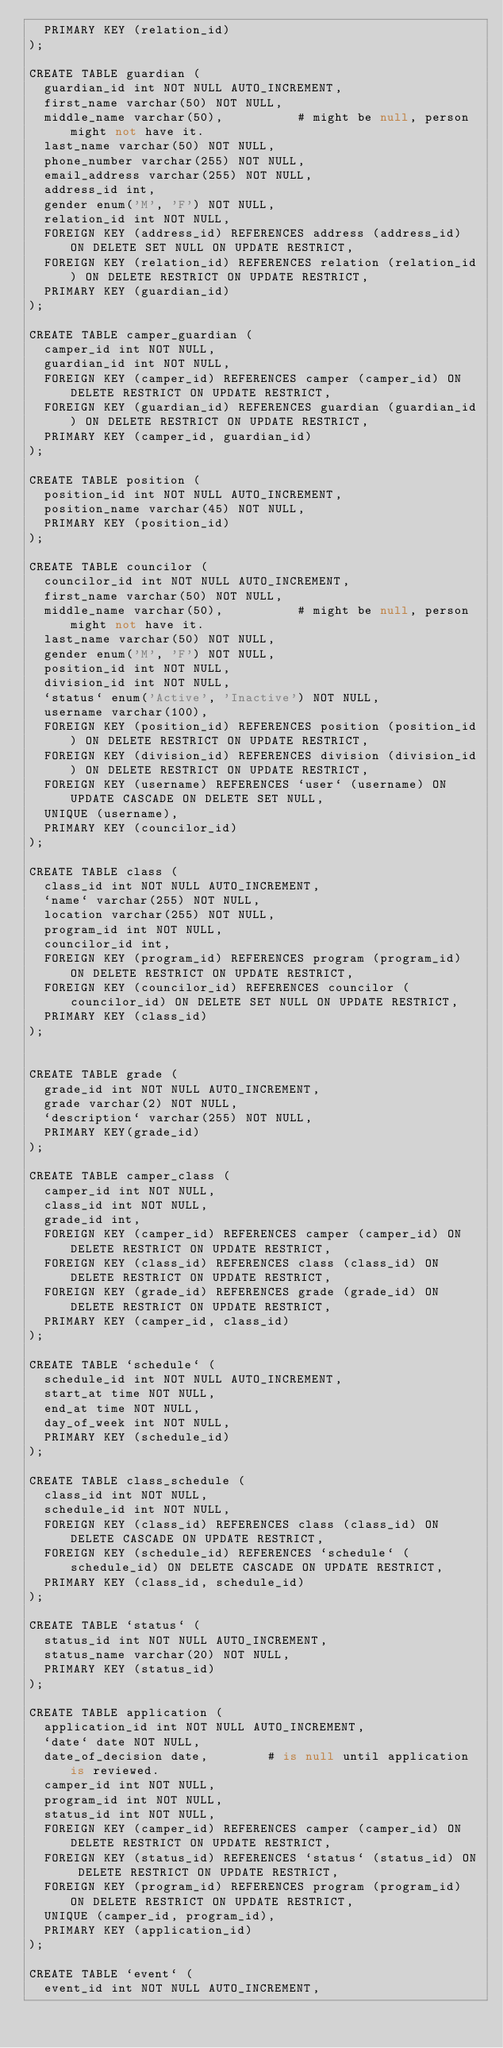<code> <loc_0><loc_0><loc_500><loc_500><_SQL_>  PRIMARY KEY (relation_id)
);

CREATE TABLE guardian (
  guardian_id int NOT NULL AUTO_INCREMENT, 
  first_name varchar(50) NOT NULL, 
  middle_name varchar(50), 			# might be null, person might not have it.
  last_name varchar(50) NOT NULL, 
  phone_number varchar(255) NOT NULL, 
  email_address varchar(255) NOT NULL, 
  address_id int, 
  gender enum('M', 'F') NOT NULL, 
  relation_id int NOT NULL, 
  FOREIGN KEY (address_id) REFERENCES address (address_id) ON DELETE SET NULL ON UPDATE RESTRICT, 
  FOREIGN KEY (relation_id) REFERENCES relation (relation_id) ON DELETE RESTRICT ON UPDATE RESTRICT, 
  PRIMARY KEY (guardian_id)
);

CREATE TABLE camper_guardian (
  camper_id int NOT NULL, 
  guardian_id int NOT NULL, 
  FOREIGN KEY (camper_id) REFERENCES camper (camper_id) ON DELETE RESTRICT ON UPDATE RESTRICT, 
  FOREIGN KEY (guardian_id) REFERENCES guardian (guardian_id) ON DELETE RESTRICT ON UPDATE RESTRICT, 
  PRIMARY KEY (camper_id, guardian_id)
);

CREATE TABLE position (
  position_id int NOT NULL AUTO_INCREMENT, 
  position_name varchar(45) NOT NULL, 
  PRIMARY KEY (position_id)
);

CREATE TABLE councilor (
  councilor_id int NOT NULL AUTO_INCREMENT, 
  first_name varchar(50) NOT NULL, 
  middle_name varchar(50), 			# might be null, person might not have it.
  last_name varchar(50) NOT NULL, 
  gender enum('M', 'F') NOT NULL, 
  position_id int NOT NULL, 
  division_id int NOT NULL, 
  `status` enum('Active', 'Inactive') NOT NULL,
  username varchar(100), 
  FOREIGN KEY (position_id) REFERENCES position (position_id) ON DELETE RESTRICT ON UPDATE RESTRICT, 
  FOREIGN KEY (division_id) REFERENCES division (division_id) ON DELETE RESTRICT ON UPDATE RESTRICT, 
  FOREIGN KEY (username) REFERENCES `user` (username) ON UPDATE CASCADE ON DELETE SET NULL, 
  UNIQUE (username),
  PRIMARY KEY (councilor_id)
);

CREATE TABLE class (
  class_id int NOT NULL AUTO_INCREMENT, 
  `name` varchar(255) NOT NULL, 
  location varchar(255) NOT NULL, 
  program_id int NOT NULL, 
  councilor_id int, 
  FOREIGN KEY (program_id) REFERENCES program (program_id) ON DELETE RESTRICT ON UPDATE RESTRICT, 
  FOREIGN KEY (councilor_id) REFERENCES councilor (councilor_id) ON DELETE SET NULL ON UPDATE RESTRICT, 
  PRIMARY KEY (class_id)
);


CREATE TABLE grade (
  grade_id int NOT NULL AUTO_INCREMENT, 
  grade varchar(2) NOT NULL, 
  `description` varchar(255) NOT NULL, 
  PRIMARY KEY(grade_id)
);

CREATE TABLE camper_class (
  camper_id int NOT NULL, 
  class_id int NOT NULL, 
  grade_id int, 
  FOREIGN KEY (camper_id) REFERENCES camper (camper_id) ON DELETE RESTRICT ON UPDATE RESTRICT, 
  FOREIGN KEY (class_id) REFERENCES class (class_id) ON DELETE RESTRICT ON UPDATE RESTRICT, 
  FOREIGN KEY (grade_id) REFERENCES grade (grade_id) ON DELETE RESTRICT ON UPDATE RESTRICT, 
  PRIMARY KEY (camper_id, class_id)
);

CREATE TABLE `schedule` (
  schedule_id int NOT NULL AUTO_INCREMENT, 
  start_at time NOT NULL, 
  end_at time NOT NULL, 
  day_of_week int NOT NULL, 
  PRIMARY KEY (schedule_id)
);

CREATE TABLE class_schedule (
  class_id int NOT NULL, 
  schedule_id int NOT NULL, 
  FOREIGN KEY (class_id) REFERENCES class (class_id) ON DELETE CASCADE ON UPDATE RESTRICT, 
  FOREIGN KEY (schedule_id) REFERENCES `schedule` (schedule_id) ON DELETE CASCADE ON UPDATE RESTRICT, 
  PRIMARY KEY (class_id, schedule_id)
);

CREATE TABLE `status` (
  status_id int NOT NULL AUTO_INCREMENT, 
  status_name varchar(20) NOT NULL, 
  PRIMARY KEY (status_id)
);

CREATE TABLE application (
  application_id int NOT NULL AUTO_INCREMENT, 
  `date` date NOT NULL, 
  date_of_decision date, 		# is null until application is reviewed.
  camper_id int NOT NULL, 
  program_id int NOT NULL, 
  status_id int NOT NULL, 
  FOREIGN KEY (camper_id) REFERENCES camper (camper_id) ON DELETE RESTRICT ON UPDATE RESTRICT, 
  FOREIGN KEY (status_id) REFERENCES `status` (status_id) ON DELETE RESTRICT ON UPDATE RESTRICT, 
  FOREIGN KEY (program_id) REFERENCES program (program_id) ON DELETE RESTRICT ON UPDATE RESTRICT, 
  UNIQUE (camper_id, program_id),
  PRIMARY KEY (application_id)
);

CREATE TABLE `event` (
  event_id int NOT NULL AUTO_INCREMENT, </code> 